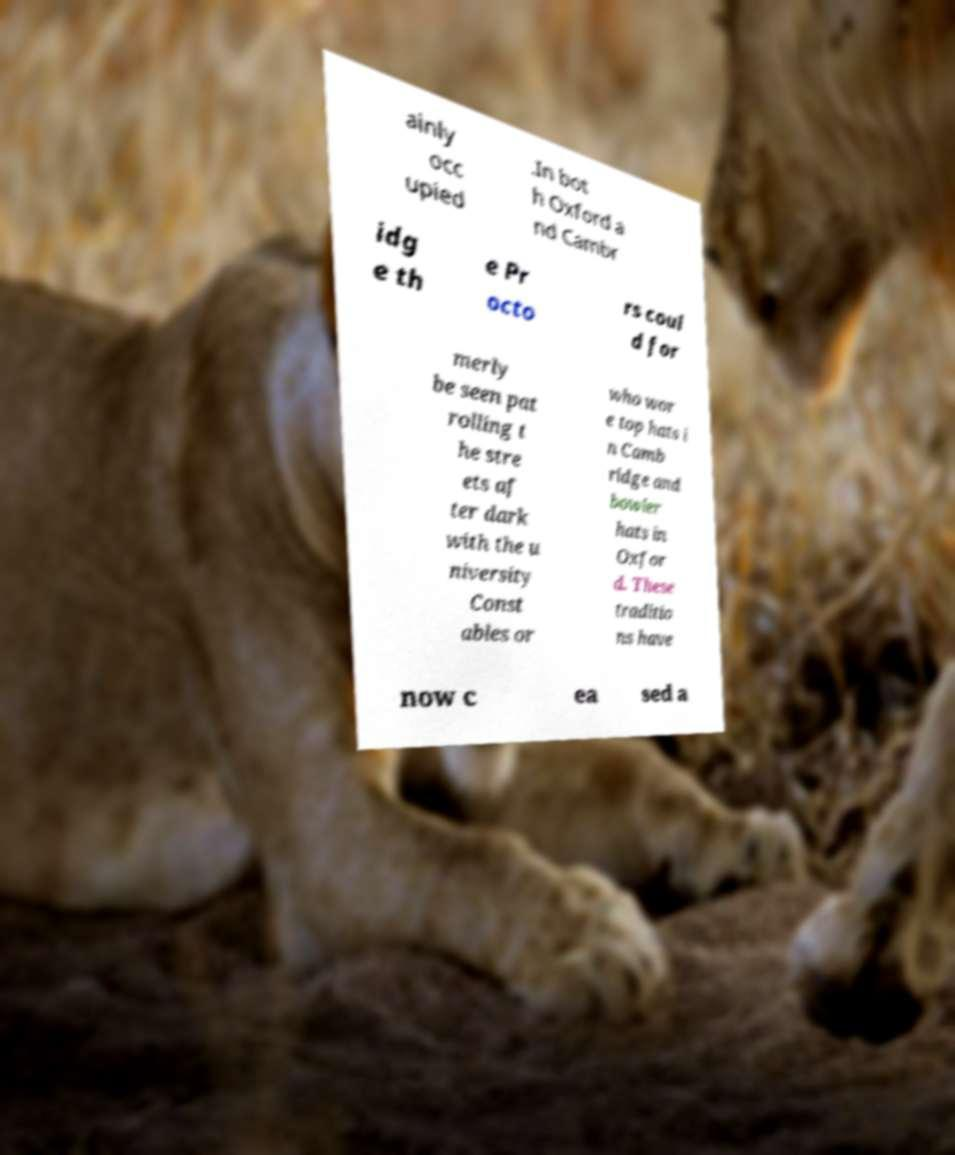Can you accurately transcribe the text from the provided image for me? ainly occ upied .In bot h Oxford a nd Cambr idg e th e Pr octo rs coul d for merly be seen pat rolling t he stre ets af ter dark with the u niversity Const ables or who wor e top hats i n Camb ridge and bowler hats in Oxfor d. These traditio ns have now c ea sed a 